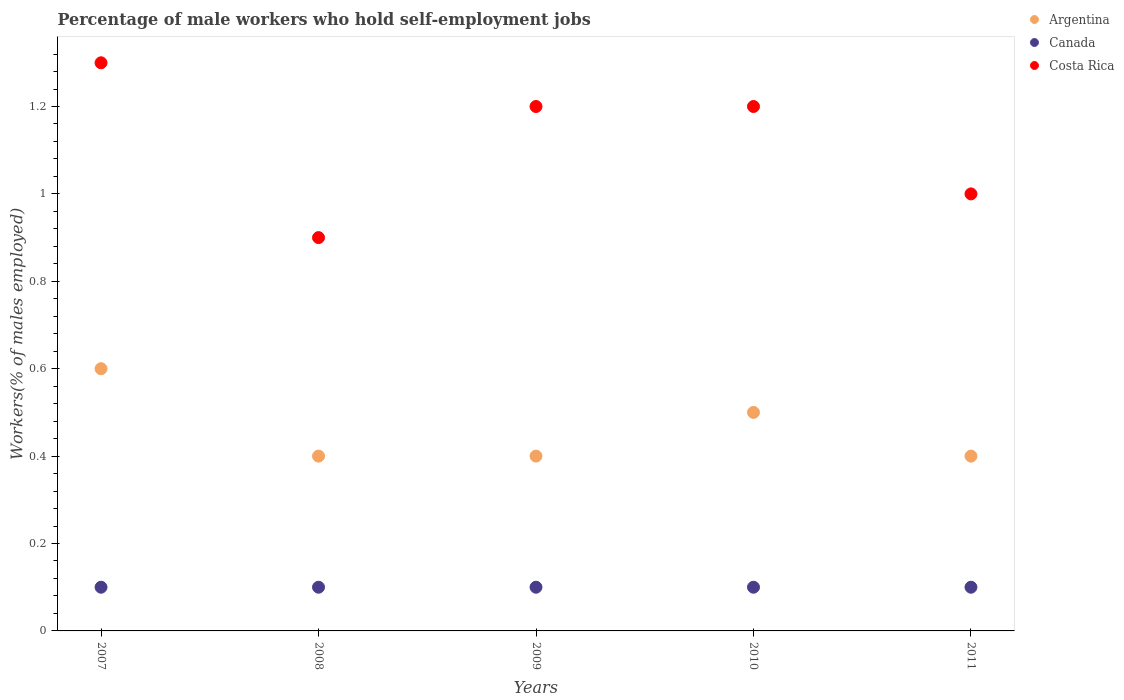How many different coloured dotlines are there?
Provide a succinct answer. 3. What is the percentage of self-employed male workers in Canada in 2009?
Provide a short and direct response. 0.1. Across all years, what is the maximum percentage of self-employed male workers in Costa Rica?
Your answer should be compact. 1.3. Across all years, what is the minimum percentage of self-employed male workers in Costa Rica?
Offer a very short reply. 0.9. What is the total percentage of self-employed male workers in Argentina in the graph?
Provide a succinct answer. 2.3. What is the difference between the percentage of self-employed male workers in Argentina in 2008 and that in 2009?
Give a very brief answer. 0. What is the difference between the percentage of self-employed male workers in Costa Rica in 2011 and the percentage of self-employed male workers in Canada in 2010?
Provide a short and direct response. 0.9. What is the average percentage of self-employed male workers in Costa Rica per year?
Your answer should be compact. 1.12. In the year 2011, what is the difference between the percentage of self-employed male workers in Argentina and percentage of self-employed male workers in Costa Rica?
Your answer should be very brief. -0.6. In how many years, is the percentage of self-employed male workers in Argentina greater than 0.6400000000000001 %?
Provide a succinct answer. 0. What is the ratio of the percentage of self-employed male workers in Canada in 2008 to that in 2011?
Make the answer very short. 1. Is the percentage of self-employed male workers in Canada in 2010 less than that in 2011?
Keep it short and to the point. No. Is the difference between the percentage of self-employed male workers in Argentina in 2007 and 2008 greater than the difference between the percentage of self-employed male workers in Costa Rica in 2007 and 2008?
Make the answer very short. No. What is the difference between the highest and the second highest percentage of self-employed male workers in Argentina?
Provide a succinct answer. 0.1. What is the difference between the highest and the lowest percentage of self-employed male workers in Canada?
Give a very brief answer. 0. Is the sum of the percentage of self-employed male workers in Argentina in 2007 and 2011 greater than the maximum percentage of self-employed male workers in Canada across all years?
Keep it short and to the point. Yes. Does the percentage of self-employed male workers in Argentina monotonically increase over the years?
Your response must be concise. No. Is the percentage of self-employed male workers in Argentina strictly greater than the percentage of self-employed male workers in Canada over the years?
Provide a short and direct response. Yes. Is the percentage of self-employed male workers in Canada strictly less than the percentage of self-employed male workers in Argentina over the years?
Your answer should be very brief. Yes. What is the difference between two consecutive major ticks on the Y-axis?
Provide a short and direct response. 0.2. Does the graph contain grids?
Keep it short and to the point. No. Where does the legend appear in the graph?
Offer a terse response. Top right. How are the legend labels stacked?
Offer a terse response. Vertical. What is the title of the graph?
Provide a succinct answer. Percentage of male workers who hold self-employment jobs. What is the label or title of the Y-axis?
Give a very brief answer. Workers(% of males employed). What is the Workers(% of males employed) of Argentina in 2007?
Offer a very short reply. 0.6. What is the Workers(% of males employed) in Canada in 2007?
Make the answer very short. 0.1. What is the Workers(% of males employed) of Costa Rica in 2007?
Your answer should be compact. 1.3. What is the Workers(% of males employed) of Argentina in 2008?
Give a very brief answer. 0.4. What is the Workers(% of males employed) in Canada in 2008?
Your answer should be very brief. 0.1. What is the Workers(% of males employed) of Costa Rica in 2008?
Your response must be concise. 0.9. What is the Workers(% of males employed) of Argentina in 2009?
Your answer should be compact. 0.4. What is the Workers(% of males employed) of Canada in 2009?
Provide a succinct answer. 0.1. What is the Workers(% of males employed) in Costa Rica in 2009?
Your answer should be compact. 1.2. What is the Workers(% of males employed) in Canada in 2010?
Provide a succinct answer. 0.1. What is the Workers(% of males employed) of Costa Rica in 2010?
Ensure brevity in your answer.  1.2. What is the Workers(% of males employed) in Argentina in 2011?
Ensure brevity in your answer.  0.4. What is the Workers(% of males employed) in Canada in 2011?
Your answer should be compact. 0.1. Across all years, what is the maximum Workers(% of males employed) in Argentina?
Your response must be concise. 0.6. Across all years, what is the maximum Workers(% of males employed) in Canada?
Keep it short and to the point. 0.1. Across all years, what is the maximum Workers(% of males employed) in Costa Rica?
Provide a succinct answer. 1.3. Across all years, what is the minimum Workers(% of males employed) in Argentina?
Your answer should be very brief. 0.4. Across all years, what is the minimum Workers(% of males employed) in Canada?
Provide a succinct answer. 0.1. Across all years, what is the minimum Workers(% of males employed) of Costa Rica?
Make the answer very short. 0.9. What is the total Workers(% of males employed) of Argentina in the graph?
Make the answer very short. 2.3. What is the total Workers(% of males employed) of Costa Rica in the graph?
Your answer should be very brief. 5.6. What is the difference between the Workers(% of males employed) of Canada in 2007 and that in 2008?
Ensure brevity in your answer.  0. What is the difference between the Workers(% of males employed) in Costa Rica in 2007 and that in 2009?
Ensure brevity in your answer.  0.1. What is the difference between the Workers(% of males employed) of Argentina in 2007 and that in 2010?
Provide a succinct answer. 0.1. What is the difference between the Workers(% of males employed) in Canada in 2007 and that in 2010?
Your response must be concise. 0. What is the difference between the Workers(% of males employed) of Costa Rica in 2007 and that in 2010?
Offer a terse response. 0.1. What is the difference between the Workers(% of males employed) of Argentina in 2007 and that in 2011?
Keep it short and to the point. 0.2. What is the difference between the Workers(% of males employed) in Canada in 2007 and that in 2011?
Provide a succinct answer. 0. What is the difference between the Workers(% of males employed) of Argentina in 2008 and that in 2009?
Provide a short and direct response. 0. What is the difference between the Workers(% of males employed) in Argentina in 2008 and that in 2010?
Provide a succinct answer. -0.1. What is the difference between the Workers(% of males employed) in Costa Rica in 2008 and that in 2010?
Ensure brevity in your answer.  -0.3. What is the difference between the Workers(% of males employed) in Canada in 2008 and that in 2011?
Offer a terse response. 0. What is the difference between the Workers(% of males employed) in Costa Rica in 2008 and that in 2011?
Provide a short and direct response. -0.1. What is the difference between the Workers(% of males employed) of Argentina in 2009 and that in 2010?
Your answer should be very brief. -0.1. What is the difference between the Workers(% of males employed) of Argentina in 2009 and that in 2011?
Provide a succinct answer. 0. What is the difference between the Workers(% of males employed) in Canada in 2009 and that in 2011?
Ensure brevity in your answer.  0. What is the difference between the Workers(% of males employed) of Argentina in 2010 and that in 2011?
Your answer should be very brief. 0.1. What is the difference between the Workers(% of males employed) of Canada in 2010 and that in 2011?
Your response must be concise. 0. What is the difference between the Workers(% of males employed) of Costa Rica in 2010 and that in 2011?
Ensure brevity in your answer.  0.2. What is the difference between the Workers(% of males employed) of Argentina in 2007 and the Workers(% of males employed) of Canada in 2008?
Provide a short and direct response. 0.5. What is the difference between the Workers(% of males employed) of Argentina in 2007 and the Workers(% of males employed) of Costa Rica in 2008?
Provide a succinct answer. -0.3. What is the difference between the Workers(% of males employed) of Argentina in 2007 and the Workers(% of males employed) of Canada in 2009?
Offer a terse response. 0.5. What is the difference between the Workers(% of males employed) in Argentina in 2007 and the Workers(% of males employed) in Costa Rica in 2009?
Provide a short and direct response. -0.6. What is the difference between the Workers(% of males employed) in Canada in 2007 and the Workers(% of males employed) in Costa Rica in 2009?
Provide a succinct answer. -1.1. What is the difference between the Workers(% of males employed) of Argentina in 2007 and the Workers(% of males employed) of Canada in 2010?
Give a very brief answer. 0.5. What is the difference between the Workers(% of males employed) in Argentina in 2007 and the Workers(% of males employed) in Costa Rica in 2010?
Give a very brief answer. -0.6. What is the difference between the Workers(% of males employed) in Canada in 2007 and the Workers(% of males employed) in Costa Rica in 2010?
Provide a short and direct response. -1.1. What is the difference between the Workers(% of males employed) of Argentina in 2007 and the Workers(% of males employed) of Canada in 2011?
Provide a short and direct response. 0.5. What is the difference between the Workers(% of males employed) in Argentina in 2007 and the Workers(% of males employed) in Costa Rica in 2011?
Offer a very short reply. -0.4. What is the difference between the Workers(% of males employed) of Canada in 2008 and the Workers(% of males employed) of Costa Rica in 2009?
Offer a terse response. -1.1. What is the difference between the Workers(% of males employed) in Argentina in 2008 and the Workers(% of males employed) in Canada in 2010?
Your answer should be very brief. 0.3. What is the difference between the Workers(% of males employed) of Argentina in 2008 and the Workers(% of males employed) of Costa Rica in 2010?
Provide a succinct answer. -0.8. What is the difference between the Workers(% of males employed) of Canada in 2008 and the Workers(% of males employed) of Costa Rica in 2010?
Provide a short and direct response. -1.1. What is the difference between the Workers(% of males employed) of Argentina in 2008 and the Workers(% of males employed) of Canada in 2011?
Offer a terse response. 0.3. What is the difference between the Workers(% of males employed) in Argentina in 2008 and the Workers(% of males employed) in Costa Rica in 2011?
Make the answer very short. -0.6. What is the difference between the Workers(% of males employed) of Argentina in 2009 and the Workers(% of males employed) of Canada in 2011?
Your answer should be compact. 0.3. What is the difference between the Workers(% of males employed) in Argentina in 2009 and the Workers(% of males employed) in Costa Rica in 2011?
Ensure brevity in your answer.  -0.6. What is the difference between the Workers(% of males employed) in Canada in 2009 and the Workers(% of males employed) in Costa Rica in 2011?
Keep it short and to the point. -0.9. What is the difference between the Workers(% of males employed) of Argentina in 2010 and the Workers(% of males employed) of Costa Rica in 2011?
Your answer should be compact. -0.5. What is the average Workers(% of males employed) of Argentina per year?
Your answer should be very brief. 0.46. What is the average Workers(% of males employed) in Costa Rica per year?
Provide a succinct answer. 1.12. In the year 2007, what is the difference between the Workers(% of males employed) of Argentina and Workers(% of males employed) of Costa Rica?
Give a very brief answer. -0.7. In the year 2007, what is the difference between the Workers(% of males employed) of Canada and Workers(% of males employed) of Costa Rica?
Offer a very short reply. -1.2. In the year 2008, what is the difference between the Workers(% of males employed) in Argentina and Workers(% of males employed) in Costa Rica?
Offer a terse response. -0.5. In the year 2009, what is the difference between the Workers(% of males employed) of Canada and Workers(% of males employed) of Costa Rica?
Provide a short and direct response. -1.1. In the year 2010, what is the difference between the Workers(% of males employed) of Argentina and Workers(% of males employed) of Canada?
Your answer should be very brief. 0.4. In the year 2011, what is the difference between the Workers(% of males employed) of Argentina and Workers(% of males employed) of Costa Rica?
Provide a succinct answer. -0.6. What is the ratio of the Workers(% of males employed) of Costa Rica in 2007 to that in 2008?
Provide a succinct answer. 1.44. What is the ratio of the Workers(% of males employed) of Argentina in 2007 to that in 2009?
Your response must be concise. 1.5. What is the ratio of the Workers(% of males employed) in Canada in 2007 to that in 2009?
Your response must be concise. 1. What is the ratio of the Workers(% of males employed) in Costa Rica in 2007 to that in 2009?
Offer a very short reply. 1.08. What is the ratio of the Workers(% of males employed) of Canada in 2007 to that in 2010?
Give a very brief answer. 1. What is the ratio of the Workers(% of males employed) of Argentina in 2007 to that in 2011?
Keep it short and to the point. 1.5. What is the ratio of the Workers(% of males employed) of Costa Rica in 2007 to that in 2011?
Your answer should be very brief. 1.3. What is the ratio of the Workers(% of males employed) in Argentina in 2008 to that in 2010?
Ensure brevity in your answer.  0.8. What is the ratio of the Workers(% of males employed) of Canada in 2008 to that in 2010?
Make the answer very short. 1. What is the ratio of the Workers(% of males employed) of Costa Rica in 2008 to that in 2010?
Give a very brief answer. 0.75. What is the ratio of the Workers(% of males employed) of Canada in 2008 to that in 2011?
Your answer should be very brief. 1. What is the ratio of the Workers(% of males employed) of Canada in 2009 to that in 2011?
Give a very brief answer. 1. What is the ratio of the Workers(% of males employed) of Costa Rica in 2009 to that in 2011?
Offer a very short reply. 1.2. What is the ratio of the Workers(% of males employed) of Argentina in 2010 to that in 2011?
Offer a very short reply. 1.25. What is the ratio of the Workers(% of males employed) of Canada in 2010 to that in 2011?
Keep it short and to the point. 1. What is the difference between the highest and the second highest Workers(% of males employed) in Argentina?
Your response must be concise. 0.1. What is the difference between the highest and the second highest Workers(% of males employed) of Costa Rica?
Provide a short and direct response. 0.1. What is the difference between the highest and the lowest Workers(% of males employed) in Canada?
Give a very brief answer. 0. 